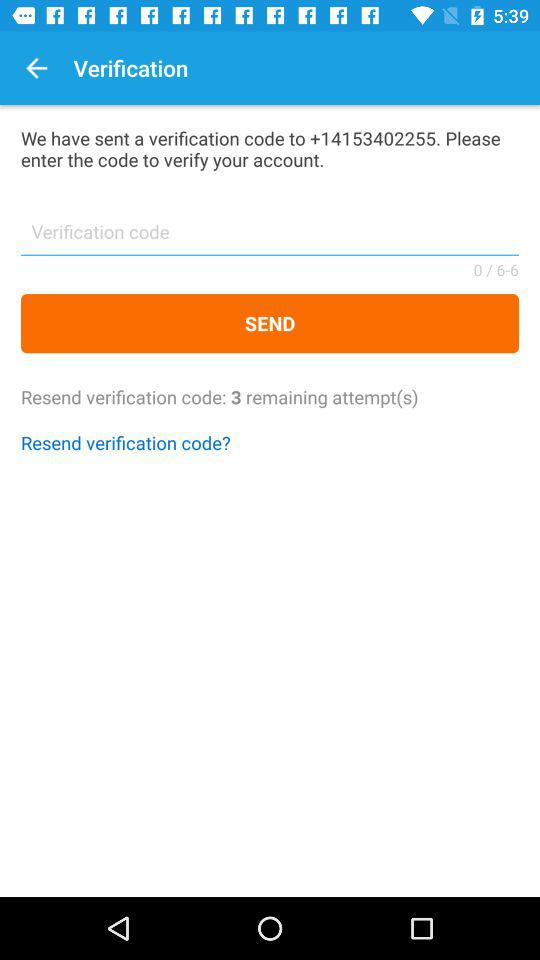What is the contact number? The contact number is +14153402255. 